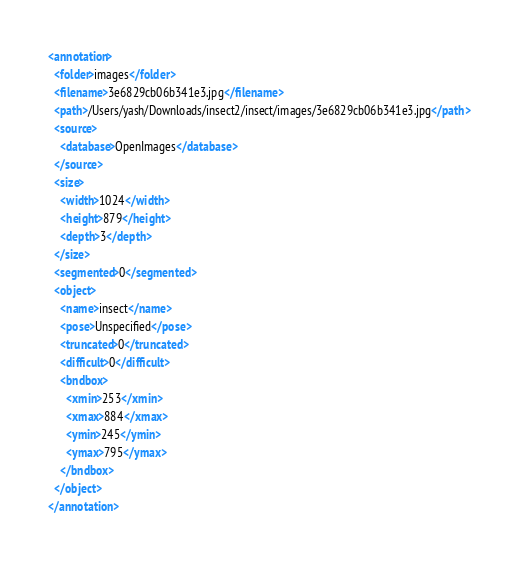Convert code to text. <code><loc_0><loc_0><loc_500><loc_500><_XML_><annotation>
  <folder>images</folder>
  <filename>3e6829cb06b341e3.jpg</filename>
  <path>/Users/yash/Downloads/insect2/insect/images/3e6829cb06b341e3.jpg</path>
  <source>
    <database>OpenImages</database>
  </source>
  <size>
    <width>1024</width>
    <height>879</height>
    <depth>3</depth>
  </size>
  <segmented>0</segmented>
  <object>
    <name>insect</name>
    <pose>Unspecified</pose>
    <truncated>0</truncated>
    <difficult>0</difficult>
    <bndbox>
      <xmin>253</xmin>
      <xmax>884</xmax>
      <ymin>245</ymin>
      <ymax>795</ymax>
    </bndbox>
  </object>
</annotation>
</code> 